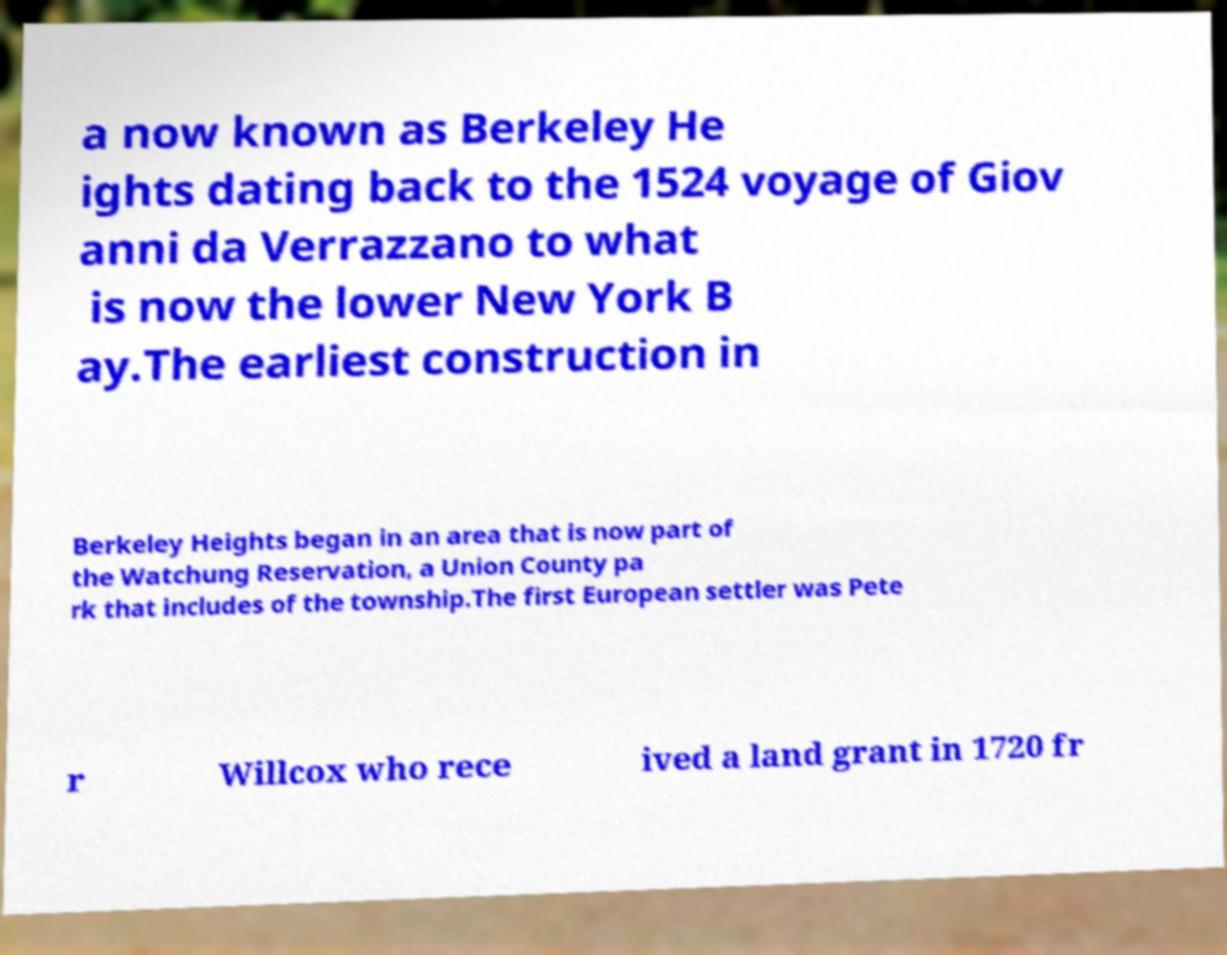Can you accurately transcribe the text from the provided image for me? a now known as Berkeley He ights dating back to the 1524 voyage of Giov anni da Verrazzano to what is now the lower New York B ay.The earliest construction in Berkeley Heights began in an area that is now part of the Watchung Reservation, a Union County pa rk that includes of the township.The first European settler was Pete r Willcox who rece ived a land grant in 1720 fr 